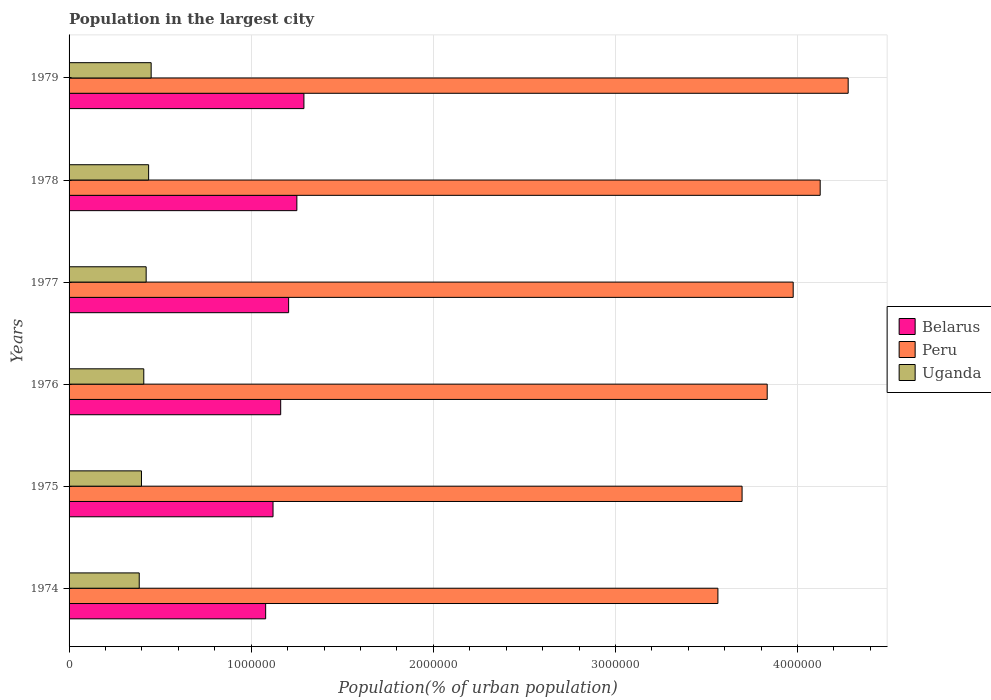How many different coloured bars are there?
Provide a succinct answer. 3. How many bars are there on the 3rd tick from the top?
Provide a short and direct response. 3. How many bars are there on the 4th tick from the bottom?
Your response must be concise. 3. What is the label of the 6th group of bars from the top?
Offer a terse response. 1974. In how many cases, is the number of bars for a given year not equal to the number of legend labels?
Your response must be concise. 0. What is the population in the largest city in Belarus in 1976?
Give a very brief answer. 1.16e+06. Across all years, what is the maximum population in the largest city in Belarus?
Offer a very short reply. 1.29e+06. Across all years, what is the minimum population in the largest city in Peru?
Provide a succinct answer. 3.56e+06. In which year was the population in the largest city in Peru maximum?
Make the answer very short. 1979. In which year was the population in the largest city in Belarus minimum?
Offer a terse response. 1974. What is the total population in the largest city in Belarus in the graph?
Provide a succinct answer. 7.11e+06. What is the difference between the population in the largest city in Uganda in 1975 and that in 1976?
Offer a very short reply. -1.27e+04. What is the difference between the population in the largest city in Belarus in 1979 and the population in the largest city in Uganda in 1975?
Your response must be concise. 8.92e+05. What is the average population in the largest city in Belarus per year?
Provide a succinct answer. 1.18e+06. In the year 1975, what is the difference between the population in the largest city in Uganda and population in the largest city in Peru?
Offer a terse response. -3.30e+06. In how many years, is the population in the largest city in Uganda greater than 3200000 %?
Your answer should be very brief. 0. What is the ratio of the population in the largest city in Uganda in 1974 to that in 1977?
Provide a short and direct response. 0.91. Is the population in the largest city in Uganda in 1974 less than that in 1977?
Offer a terse response. Yes. What is the difference between the highest and the second highest population in the largest city in Peru?
Make the answer very short. 1.54e+05. What is the difference between the highest and the lowest population in the largest city in Belarus?
Your answer should be very brief. 2.10e+05. What does the 1st bar from the top in 1979 represents?
Your response must be concise. Uganda. What does the 3rd bar from the bottom in 1976 represents?
Your answer should be compact. Uganda. How many bars are there?
Give a very brief answer. 18. Are all the bars in the graph horizontal?
Your response must be concise. Yes. How are the legend labels stacked?
Your answer should be very brief. Vertical. What is the title of the graph?
Provide a succinct answer. Population in the largest city. What is the label or title of the X-axis?
Give a very brief answer. Population(% of urban population). What is the label or title of the Y-axis?
Ensure brevity in your answer.  Years. What is the Population(% of urban population) of Belarus in 1974?
Give a very brief answer. 1.08e+06. What is the Population(% of urban population) of Peru in 1974?
Make the answer very short. 3.56e+06. What is the Population(% of urban population) in Uganda in 1974?
Provide a short and direct response. 3.85e+05. What is the Population(% of urban population) in Belarus in 1975?
Ensure brevity in your answer.  1.12e+06. What is the Population(% of urban population) of Peru in 1975?
Your answer should be very brief. 3.70e+06. What is the Population(% of urban population) in Uganda in 1975?
Provide a succinct answer. 3.98e+05. What is the Population(% of urban population) of Belarus in 1976?
Your response must be concise. 1.16e+06. What is the Population(% of urban population) in Peru in 1976?
Give a very brief answer. 3.83e+06. What is the Population(% of urban population) in Uganda in 1976?
Keep it short and to the point. 4.10e+05. What is the Population(% of urban population) in Belarus in 1977?
Provide a succinct answer. 1.21e+06. What is the Population(% of urban population) of Peru in 1977?
Provide a short and direct response. 3.98e+06. What is the Population(% of urban population) in Uganda in 1977?
Your response must be concise. 4.23e+05. What is the Population(% of urban population) of Belarus in 1978?
Offer a terse response. 1.25e+06. What is the Population(% of urban population) in Peru in 1978?
Give a very brief answer. 4.12e+06. What is the Population(% of urban population) of Uganda in 1978?
Offer a very short reply. 4.37e+05. What is the Population(% of urban population) of Belarus in 1979?
Your response must be concise. 1.29e+06. What is the Population(% of urban population) in Peru in 1979?
Your answer should be compact. 4.28e+06. What is the Population(% of urban population) in Uganda in 1979?
Offer a very short reply. 4.51e+05. Across all years, what is the maximum Population(% of urban population) of Belarus?
Give a very brief answer. 1.29e+06. Across all years, what is the maximum Population(% of urban population) of Peru?
Your answer should be very brief. 4.28e+06. Across all years, what is the maximum Population(% of urban population) in Uganda?
Keep it short and to the point. 4.51e+05. Across all years, what is the minimum Population(% of urban population) of Belarus?
Offer a very short reply. 1.08e+06. Across all years, what is the minimum Population(% of urban population) in Peru?
Offer a very short reply. 3.56e+06. Across all years, what is the minimum Population(% of urban population) of Uganda?
Make the answer very short. 3.85e+05. What is the total Population(% of urban population) in Belarus in the graph?
Provide a succinct answer. 7.11e+06. What is the total Population(% of urban population) of Peru in the graph?
Give a very brief answer. 2.35e+07. What is the total Population(% of urban population) of Uganda in the graph?
Your answer should be compact. 2.50e+06. What is the difference between the Population(% of urban population) of Belarus in 1974 and that in 1975?
Make the answer very short. -4.05e+04. What is the difference between the Population(% of urban population) of Peru in 1974 and that in 1975?
Provide a short and direct response. -1.33e+05. What is the difference between the Population(% of urban population) of Uganda in 1974 and that in 1975?
Provide a succinct answer. -1.23e+04. What is the difference between the Population(% of urban population) of Belarus in 1974 and that in 1976?
Your response must be concise. -8.26e+04. What is the difference between the Population(% of urban population) in Peru in 1974 and that in 1976?
Your response must be concise. -2.71e+05. What is the difference between the Population(% of urban population) of Uganda in 1974 and that in 1976?
Make the answer very short. -2.50e+04. What is the difference between the Population(% of urban population) of Belarus in 1974 and that in 1977?
Provide a succinct answer. -1.26e+05. What is the difference between the Population(% of urban population) in Peru in 1974 and that in 1977?
Make the answer very short. -4.13e+05. What is the difference between the Population(% of urban population) in Uganda in 1974 and that in 1977?
Offer a terse response. -3.80e+04. What is the difference between the Population(% of urban population) in Belarus in 1974 and that in 1978?
Your response must be concise. -1.71e+05. What is the difference between the Population(% of urban population) in Peru in 1974 and that in 1978?
Provide a short and direct response. -5.62e+05. What is the difference between the Population(% of urban population) of Uganda in 1974 and that in 1978?
Your response must be concise. -5.15e+04. What is the difference between the Population(% of urban population) of Belarus in 1974 and that in 1979?
Offer a terse response. -2.10e+05. What is the difference between the Population(% of urban population) in Peru in 1974 and that in 1979?
Your response must be concise. -7.15e+05. What is the difference between the Population(% of urban population) of Uganda in 1974 and that in 1979?
Keep it short and to the point. -6.54e+04. What is the difference between the Population(% of urban population) in Belarus in 1975 and that in 1976?
Provide a short and direct response. -4.21e+04. What is the difference between the Population(% of urban population) of Peru in 1975 and that in 1976?
Provide a succinct answer. -1.38e+05. What is the difference between the Population(% of urban population) in Uganda in 1975 and that in 1976?
Keep it short and to the point. -1.27e+04. What is the difference between the Population(% of urban population) of Belarus in 1975 and that in 1977?
Ensure brevity in your answer.  -8.56e+04. What is the difference between the Population(% of urban population) in Peru in 1975 and that in 1977?
Ensure brevity in your answer.  -2.81e+05. What is the difference between the Population(% of urban population) of Uganda in 1975 and that in 1977?
Your answer should be compact. -2.57e+04. What is the difference between the Population(% of urban population) in Belarus in 1975 and that in 1978?
Offer a very short reply. -1.31e+05. What is the difference between the Population(% of urban population) of Peru in 1975 and that in 1978?
Keep it short and to the point. -4.29e+05. What is the difference between the Population(% of urban population) of Uganda in 1975 and that in 1978?
Give a very brief answer. -3.92e+04. What is the difference between the Population(% of urban population) in Belarus in 1975 and that in 1979?
Your answer should be very brief. -1.70e+05. What is the difference between the Population(% of urban population) of Peru in 1975 and that in 1979?
Your answer should be compact. -5.83e+05. What is the difference between the Population(% of urban population) in Uganda in 1975 and that in 1979?
Make the answer very short. -5.32e+04. What is the difference between the Population(% of urban population) in Belarus in 1976 and that in 1977?
Your answer should be very brief. -4.35e+04. What is the difference between the Population(% of urban population) in Peru in 1976 and that in 1977?
Your response must be concise. -1.43e+05. What is the difference between the Population(% of urban population) of Uganda in 1976 and that in 1977?
Offer a terse response. -1.31e+04. What is the difference between the Population(% of urban population) of Belarus in 1976 and that in 1978?
Keep it short and to the point. -8.88e+04. What is the difference between the Population(% of urban population) in Peru in 1976 and that in 1978?
Provide a short and direct response. -2.91e+05. What is the difference between the Population(% of urban population) of Uganda in 1976 and that in 1978?
Make the answer very short. -2.66e+04. What is the difference between the Population(% of urban population) of Belarus in 1976 and that in 1979?
Keep it short and to the point. -1.28e+05. What is the difference between the Population(% of urban population) in Peru in 1976 and that in 1979?
Provide a succinct answer. -4.45e+05. What is the difference between the Population(% of urban population) in Uganda in 1976 and that in 1979?
Keep it short and to the point. -4.05e+04. What is the difference between the Population(% of urban population) in Belarus in 1977 and that in 1978?
Provide a succinct answer. -4.52e+04. What is the difference between the Population(% of urban population) in Peru in 1977 and that in 1978?
Provide a succinct answer. -1.48e+05. What is the difference between the Population(% of urban population) of Uganda in 1977 and that in 1978?
Provide a short and direct response. -1.35e+04. What is the difference between the Population(% of urban population) in Belarus in 1977 and that in 1979?
Your response must be concise. -8.40e+04. What is the difference between the Population(% of urban population) of Peru in 1977 and that in 1979?
Make the answer very short. -3.02e+05. What is the difference between the Population(% of urban population) of Uganda in 1977 and that in 1979?
Ensure brevity in your answer.  -2.74e+04. What is the difference between the Population(% of urban population) of Belarus in 1978 and that in 1979?
Your response must be concise. -3.88e+04. What is the difference between the Population(% of urban population) in Peru in 1978 and that in 1979?
Give a very brief answer. -1.54e+05. What is the difference between the Population(% of urban population) in Uganda in 1978 and that in 1979?
Make the answer very short. -1.39e+04. What is the difference between the Population(% of urban population) of Belarus in 1974 and the Population(% of urban population) of Peru in 1975?
Give a very brief answer. -2.62e+06. What is the difference between the Population(% of urban population) of Belarus in 1974 and the Population(% of urban population) of Uganda in 1975?
Ensure brevity in your answer.  6.82e+05. What is the difference between the Population(% of urban population) in Peru in 1974 and the Population(% of urban population) in Uganda in 1975?
Your response must be concise. 3.17e+06. What is the difference between the Population(% of urban population) in Belarus in 1974 and the Population(% of urban population) in Peru in 1976?
Provide a short and direct response. -2.75e+06. What is the difference between the Population(% of urban population) in Belarus in 1974 and the Population(% of urban population) in Uganda in 1976?
Provide a short and direct response. 6.69e+05. What is the difference between the Population(% of urban population) in Peru in 1974 and the Population(% of urban population) in Uganda in 1976?
Keep it short and to the point. 3.15e+06. What is the difference between the Population(% of urban population) of Belarus in 1974 and the Population(% of urban population) of Peru in 1977?
Provide a short and direct response. -2.90e+06. What is the difference between the Population(% of urban population) in Belarus in 1974 and the Population(% of urban population) in Uganda in 1977?
Provide a succinct answer. 6.56e+05. What is the difference between the Population(% of urban population) of Peru in 1974 and the Population(% of urban population) of Uganda in 1977?
Your response must be concise. 3.14e+06. What is the difference between the Population(% of urban population) in Belarus in 1974 and the Population(% of urban population) in Peru in 1978?
Ensure brevity in your answer.  -3.04e+06. What is the difference between the Population(% of urban population) in Belarus in 1974 and the Population(% of urban population) in Uganda in 1978?
Your response must be concise. 6.43e+05. What is the difference between the Population(% of urban population) in Peru in 1974 and the Population(% of urban population) in Uganda in 1978?
Offer a very short reply. 3.13e+06. What is the difference between the Population(% of urban population) in Belarus in 1974 and the Population(% of urban population) in Peru in 1979?
Provide a succinct answer. -3.20e+06. What is the difference between the Population(% of urban population) of Belarus in 1974 and the Population(% of urban population) of Uganda in 1979?
Provide a short and direct response. 6.29e+05. What is the difference between the Population(% of urban population) in Peru in 1974 and the Population(% of urban population) in Uganda in 1979?
Offer a terse response. 3.11e+06. What is the difference between the Population(% of urban population) in Belarus in 1975 and the Population(% of urban population) in Peru in 1976?
Offer a terse response. -2.71e+06. What is the difference between the Population(% of urban population) in Belarus in 1975 and the Population(% of urban population) in Uganda in 1976?
Provide a short and direct response. 7.10e+05. What is the difference between the Population(% of urban population) in Peru in 1975 and the Population(% of urban population) in Uganda in 1976?
Your answer should be compact. 3.29e+06. What is the difference between the Population(% of urban population) of Belarus in 1975 and the Population(% of urban population) of Peru in 1977?
Ensure brevity in your answer.  -2.86e+06. What is the difference between the Population(% of urban population) of Belarus in 1975 and the Population(% of urban population) of Uganda in 1977?
Your answer should be very brief. 6.97e+05. What is the difference between the Population(% of urban population) of Peru in 1975 and the Population(% of urban population) of Uganda in 1977?
Your response must be concise. 3.27e+06. What is the difference between the Population(% of urban population) in Belarus in 1975 and the Population(% of urban population) in Peru in 1978?
Offer a terse response. -3.00e+06. What is the difference between the Population(% of urban population) in Belarus in 1975 and the Population(% of urban population) in Uganda in 1978?
Provide a succinct answer. 6.83e+05. What is the difference between the Population(% of urban population) in Peru in 1975 and the Population(% of urban population) in Uganda in 1978?
Ensure brevity in your answer.  3.26e+06. What is the difference between the Population(% of urban population) of Belarus in 1975 and the Population(% of urban population) of Peru in 1979?
Provide a succinct answer. -3.16e+06. What is the difference between the Population(% of urban population) in Belarus in 1975 and the Population(% of urban population) in Uganda in 1979?
Keep it short and to the point. 6.69e+05. What is the difference between the Population(% of urban population) of Peru in 1975 and the Population(% of urban population) of Uganda in 1979?
Your answer should be very brief. 3.24e+06. What is the difference between the Population(% of urban population) of Belarus in 1976 and the Population(% of urban population) of Peru in 1977?
Make the answer very short. -2.81e+06. What is the difference between the Population(% of urban population) of Belarus in 1976 and the Population(% of urban population) of Uganda in 1977?
Provide a succinct answer. 7.39e+05. What is the difference between the Population(% of urban population) in Peru in 1976 and the Population(% of urban population) in Uganda in 1977?
Provide a succinct answer. 3.41e+06. What is the difference between the Population(% of urban population) of Belarus in 1976 and the Population(% of urban population) of Peru in 1978?
Offer a terse response. -2.96e+06. What is the difference between the Population(% of urban population) of Belarus in 1976 and the Population(% of urban population) of Uganda in 1978?
Your answer should be compact. 7.25e+05. What is the difference between the Population(% of urban population) of Peru in 1976 and the Population(% of urban population) of Uganda in 1978?
Give a very brief answer. 3.40e+06. What is the difference between the Population(% of urban population) in Belarus in 1976 and the Population(% of urban population) in Peru in 1979?
Provide a short and direct response. -3.12e+06. What is the difference between the Population(% of urban population) of Belarus in 1976 and the Population(% of urban population) of Uganda in 1979?
Offer a very short reply. 7.11e+05. What is the difference between the Population(% of urban population) in Peru in 1976 and the Population(% of urban population) in Uganda in 1979?
Ensure brevity in your answer.  3.38e+06. What is the difference between the Population(% of urban population) of Belarus in 1977 and the Population(% of urban population) of Peru in 1978?
Make the answer very short. -2.92e+06. What is the difference between the Population(% of urban population) of Belarus in 1977 and the Population(% of urban population) of Uganda in 1978?
Offer a terse response. 7.69e+05. What is the difference between the Population(% of urban population) of Peru in 1977 and the Population(% of urban population) of Uganda in 1978?
Provide a short and direct response. 3.54e+06. What is the difference between the Population(% of urban population) in Belarus in 1977 and the Population(% of urban population) in Peru in 1979?
Offer a very short reply. -3.07e+06. What is the difference between the Population(% of urban population) in Belarus in 1977 and the Population(% of urban population) in Uganda in 1979?
Give a very brief answer. 7.55e+05. What is the difference between the Population(% of urban population) of Peru in 1977 and the Population(% of urban population) of Uganda in 1979?
Make the answer very short. 3.53e+06. What is the difference between the Population(% of urban population) of Belarus in 1978 and the Population(% of urban population) of Peru in 1979?
Your answer should be very brief. -3.03e+06. What is the difference between the Population(% of urban population) in Belarus in 1978 and the Population(% of urban population) in Uganda in 1979?
Offer a terse response. 8.00e+05. What is the difference between the Population(% of urban population) of Peru in 1978 and the Population(% of urban population) of Uganda in 1979?
Your answer should be compact. 3.67e+06. What is the average Population(% of urban population) of Belarus per year?
Ensure brevity in your answer.  1.18e+06. What is the average Population(% of urban population) in Peru per year?
Provide a short and direct response. 3.91e+06. What is the average Population(% of urban population) of Uganda per year?
Provide a succinct answer. 4.17e+05. In the year 1974, what is the difference between the Population(% of urban population) of Belarus and Population(% of urban population) of Peru?
Provide a short and direct response. -2.48e+06. In the year 1974, what is the difference between the Population(% of urban population) in Belarus and Population(% of urban population) in Uganda?
Offer a very short reply. 6.94e+05. In the year 1974, what is the difference between the Population(% of urban population) in Peru and Population(% of urban population) in Uganda?
Provide a short and direct response. 3.18e+06. In the year 1975, what is the difference between the Population(% of urban population) of Belarus and Population(% of urban population) of Peru?
Offer a terse response. -2.58e+06. In the year 1975, what is the difference between the Population(% of urban population) of Belarus and Population(% of urban population) of Uganda?
Make the answer very short. 7.22e+05. In the year 1975, what is the difference between the Population(% of urban population) of Peru and Population(% of urban population) of Uganda?
Offer a terse response. 3.30e+06. In the year 1976, what is the difference between the Population(% of urban population) in Belarus and Population(% of urban population) in Peru?
Your response must be concise. -2.67e+06. In the year 1976, what is the difference between the Population(% of urban population) of Belarus and Population(% of urban population) of Uganda?
Give a very brief answer. 7.52e+05. In the year 1976, what is the difference between the Population(% of urban population) of Peru and Population(% of urban population) of Uganda?
Provide a short and direct response. 3.42e+06. In the year 1977, what is the difference between the Population(% of urban population) of Belarus and Population(% of urban population) of Peru?
Provide a short and direct response. -2.77e+06. In the year 1977, what is the difference between the Population(% of urban population) in Belarus and Population(% of urban population) in Uganda?
Your answer should be very brief. 7.82e+05. In the year 1977, what is the difference between the Population(% of urban population) in Peru and Population(% of urban population) in Uganda?
Make the answer very short. 3.55e+06. In the year 1978, what is the difference between the Population(% of urban population) in Belarus and Population(% of urban population) in Peru?
Provide a succinct answer. -2.87e+06. In the year 1978, what is the difference between the Population(% of urban population) of Belarus and Population(% of urban population) of Uganda?
Your answer should be compact. 8.14e+05. In the year 1978, what is the difference between the Population(% of urban population) in Peru and Population(% of urban population) in Uganda?
Provide a succinct answer. 3.69e+06. In the year 1979, what is the difference between the Population(% of urban population) of Belarus and Population(% of urban population) of Peru?
Give a very brief answer. -2.99e+06. In the year 1979, what is the difference between the Population(% of urban population) of Belarus and Population(% of urban population) of Uganda?
Give a very brief answer. 8.39e+05. In the year 1979, what is the difference between the Population(% of urban population) of Peru and Population(% of urban population) of Uganda?
Your answer should be compact. 3.83e+06. What is the ratio of the Population(% of urban population) of Belarus in 1974 to that in 1975?
Provide a short and direct response. 0.96. What is the ratio of the Population(% of urban population) in Peru in 1974 to that in 1975?
Your response must be concise. 0.96. What is the ratio of the Population(% of urban population) in Uganda in 1974 to that in 1975?
Keep it short and to the point. 0.97. What is the ratio of the Population(% of urban population) of Belarus in 1974 to that in 1976?
Your response must be concise. 0.93. What is the ratio of the Population(% of urban population) in Peru in 1974 to that in 1976?
Provide a succinct answer. 0.93. What is the ratio of the Population(% of urban population) in Uganda in 1974 to that in 1976?
Give a very brief answer. 0.94. What is the ratio of the Population(% of urban population) in Belarus in 1974 to that in 1977?
Offer a terse response. 0.9. What is the ratio of the Population(% of urban population) of Peru in 1974 to that in 1977?
Offer a very short reply. 0.9. What is the ratio of the Population(% of urban population) in Uganda in 1974 to that in 1977?
Offer a terse response. 0.91. What is the ratio of the Population(% of urban population) in Belarus in 1974 to that in 1978?
Offer a terse response. 0.86. What is the ratio of the Population(% of urban population) of Peru in 1974 to that in 1978?
Your answer should be very brief. 0.86. What is the ratio of the Population(% of urban population) of Uganda in 1974 to that in 1978?
Make the answer very short. 0.88. What is the ratio of the Population(% of urban population) of Belarus in 1974 to that in 1979?
Provide a short and direct response. 0.84. What is the ratio of the Population(% of urban population) in Peru in 1974 to that in 1979?
Keep it short and to the point. 0.83. What is the ratio of the Population(% of urban population) of Uganda in 1974 to that in 1979?
Your answer should be very brief. 0.85. What is the ratio of the Population(% of urban population) in Belarus in 1975 to that in 1976?
Your answer should be compact. 0.96. What is the ratio of the Population(% of urban population) of Peru in 1975 to that in 1976?
Provide a succinct answer. 0.96. What is the ratio of the Population(% of urban population) of Uganda in 1975 to that in 1976?
Make the answer very short. 0.97. What is the ratio of the Population(% of urban population) in Belarus in 1975 to that in 1977?
Your answer should be very brief. 0.93. What is the ratio of the Population(% of urban population) of Peru in 1975 to that in 1977?
Offer a terse response. 0.93. What is the ratio of the Population(% of urban population) of Uganda in 1975 to that in 1977?
Give a very brief answer. 0.94. What is the ratio of the Population(% of urban population) of Belarus in 1975 to that in 1978?
Provide a succinct answer. 0.9. What is the ratio of the Population(% of urban population) in Peru in 1975 to that in 1978?
Provide a succinct answer. 0.9. What is the ratio of the Population(% of urban population) in Uganda in 1975 to that in 1978?
Give a very brief answer. 0.91. What is the ratio of the Population(% of urban population) of Belarus in 1975 to that in 1979?
Your answer should be compact. 0.87. What is the ratio of the Population(% of urban population) in Peru in 1975 to that in 1979?
Provide a short and direct response. 0.86. What is the ratio of the Population(% of urban population) in Uganda in 1975 to that in 1979?
Your answer should be very brief. 0.88. What is the ratio of the Population(% of urban population) in Belarus in 1976 to that in 1977?
Provide a short and direct response. 0.96. What is the ratio of the Population(% of urban population) of Peru in 1976 to that in 1977?
Make the answer very short. 0.96. What is the ratio of the Population(% of urban population) of Uganda in 1976 to that in 1977?
Your response must be concise. 0.97. What is the ratio of the Population(% of urban population) in Belarus in 1976 to that in 1978?
Make the answer very short. 0.93. What is the ratio of the Population(% of urban population) of Peru in 1976 to that in 1978?
Keep it short and to the point. 0.93. What is the ratio of the Population(% of urban population) of Uganda in 1976 to that in 1978?
Provide a short and direct response. 0.94. What is the ratio of the Population(% of urban population) of Belarus in 1976 to that in 1979?
Make the answer very short. 0.9. What is the ratio of the Population(% of urban population) of Peru in 1976 to that in 1979?
Your response must be concise. 0.9. What is the ratio of the Population(% of urban population) of Uganda in 1976 to that in 1979?
Offer a terse response. 0.91. What is the ratio of the Population(% of urban population) of Belarus in 1977 to that in 1978?
Provide a short and direct response. 0.96. What is the ratio of the Population(% of urban population) of Peru in 1977 to that in 1978?
Your response must be concise. 0.96. What is the ratio of the Population(% of urban population) of Uganda in 1977 to that in 1978?
Ensure brevity in your answer.  0.97. What is the ratio of the Population(% of urban population) in Belarus in 1977 to that in 1979?
Ensure brevity in your answer.  0.93. What is the ratio of the Population(% of urban population) in Peru in 1977 to that in 1979?
Make the answer very short. 0.93. What is the ratio of the Population(% of urban population) in Uganda in 1977 to that in 1979?
Ensure brevity in your answer.  0.94. What is the ratio of the Population(% of urban population) in Belarus in 1978 to that in 1979?
Your answer should be compact. 0.97. What is the ratio of the Population(% of urban population) in Peru in 1978 to that in 1979?
Your response must be concise. 0.96. What is the ratio of the Population(% of urban population) in Uganda in 1978 to that in 1979?
Offer a terse response. 0.97. What is the difference between the highest and the second highest Population(% of urban population) of Belarus?
Make the answer very short. 3.88e+04. What is the difference between the highest and the second highest Population(% of urban population) of Peru?
Your answer should be compact. 1.54e+05. What is the difference between the highest and the second highest Population(% of urban population) of Uganda?
Give a very brief answer. 1.39e+04. What is the difference between the highest and the lowest Population(% of urban population) in Belarus?
Make the answer very short. 2.10e+05. What is the difference between the highest and the lowest Population(% of urban population) in Peru?
Offer a terse response. 7.15e+05. What is the difference between the highest and the lowest Population(% of urban population) of Uganda?
Your response must be concise. 6.54e+04. 